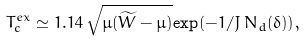<formula> <loc_0><loc_0><loc_500><loc_500>T _ { c } ^ { e x } \simeq 1 . 1 4 \, \sqrt { \mu ( \widetilde { W } - \mu ) } { \exp } { ( - 1 / J \, N _ { d } ( \delta ) ) } ,</formula> 